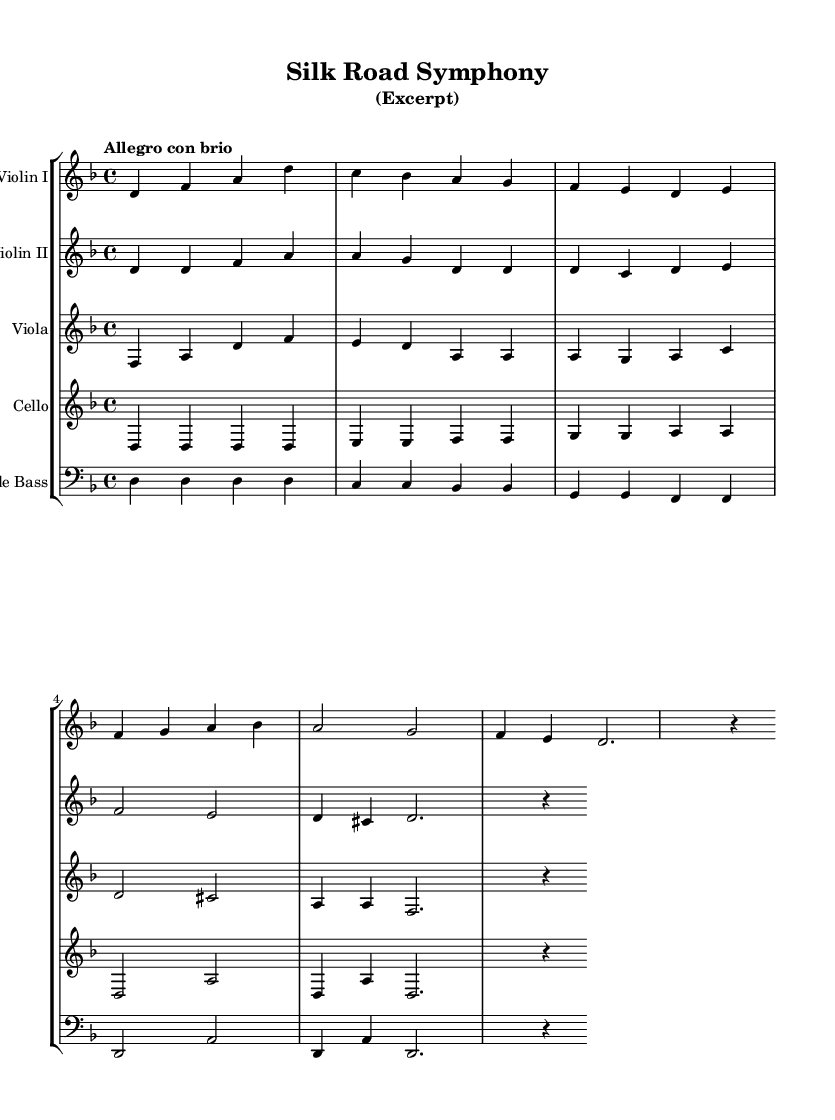What is the key signature of this music? The key signature is indicated by the sharps or flats at the beginning of the staff. In this score, there are no sharps or flats, which means it is in D minor, as shown by the use of the note D prominently in the melody.
Answer: D minor What is the time signature of this composition? The time signature is found at the beginning of the music, represented as a fraction. In this score, the time signature shows 4 over 4, meaning there are four beats in each measure and the quarter note gets one beat.
Answer: 4/4 What is the tempo marking for this excerpt? The tempo is indicated as "Allegro con brio," which translates to a fast tempo with spirit. This marking is found above the music staff at the beginning of the excerpt.
Answer: Allegro con brio How many measures are in this excerpt? To find the number of measures, count the vertical lines separating groups of notes in the score. This excerpt has a total of four measures, which can be counted from the start to the end of the provided music staff.
Answer: Four Which instruments are included in this orchestral composition? The instruments are listed at the beginning of each staff section in the score. The excerpt features Violin I, Violin II, Viola, Cello, and Double Bass.
Answer: Violin I, Violin II, Viola, Cello, Double Bass What is the main theme characterized by the violin in measure 1? To determine the main theme, analyze the notes played by the violin in the first measure. The theme starts with a melodic line beginning on D, consisting of ascending and descending notes, establishing the primary motif.
Answer: D, F, A 